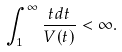<formula> <loc_0><loc_0><loc_500><loc_500>\int _ { 1 } ^ { \infty } \frac { t d t } { V ( t ) } < \infty .</formula> 